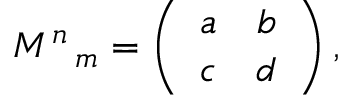Convert formula to latex. <formula><loc_0><loc_0><loc_500><loc_500>M ^ { n } \, _ { m } = \left ( \begin{array} { c c } { a } & { b } \\ { c } & { d } \end{array} \right ) ,</formula> 